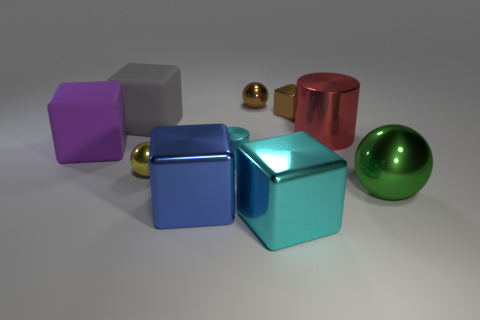Subtract all tiny metal cubes. How many cubes are left? 4 Subtract all blue blocks. How many blocks are left? 4 Subtract all red cubes. Subtract all green cylinders. How many cubes are left? 5 Subtract all balls. How many objects are left? 7 Add 10 big yellow matte things. How many big yellow matte things exist? 10 Subtract 0 yellow cylinders. How many objects are left? 10 Subtract all large blocks. Subtract all large cyan cubes. How many objects are left? 5 Add 8 green metallic balls. How many green metallic balls are left? 9 